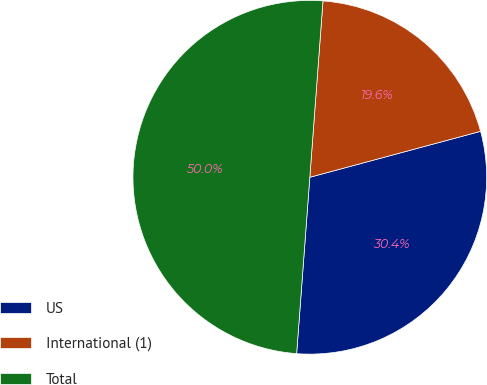<chart> <loc_0><loc_0><loc_500><loc_500><pie_chart><fcel>US<fcel>International (1)<fcel>Total<nl><fcel>30.37%<fcel>19.63%<fcel>50.0%<nl></chart> 